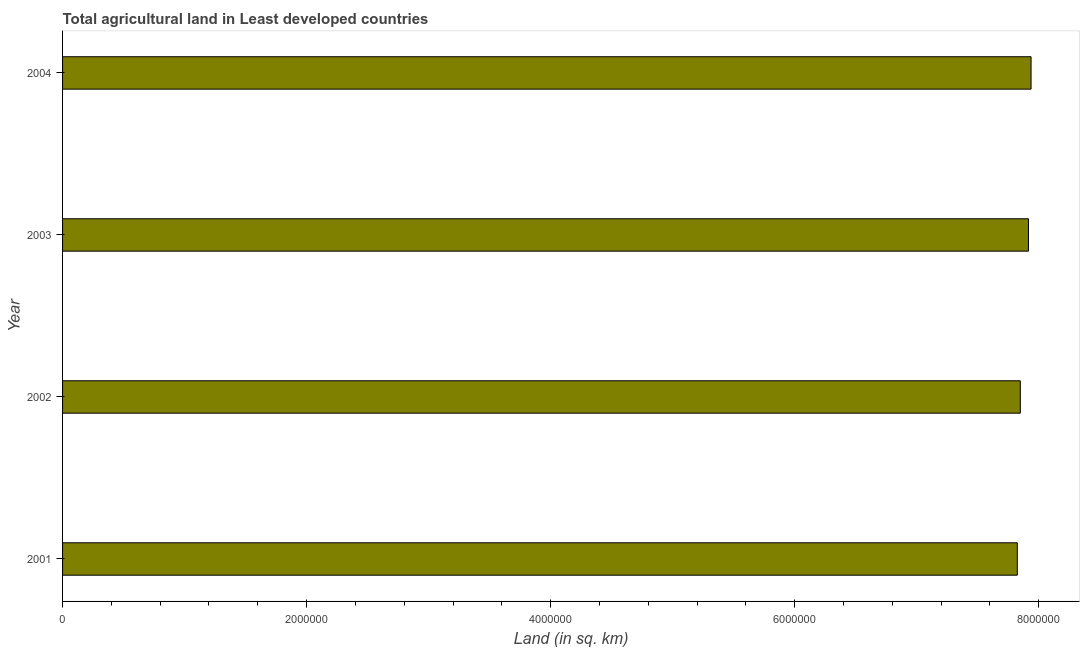What is the title of the graph?
Your response must be concise. Total agricultural land in Least developed countries. What is the label or title of the X-axis?
Your answer should be compact. Land (in sq. km). What is the agricultural land in 2004?
Your response must be concise. 7.94e+06. Across all years, what is the maximum agricultural land?
Offer a terse response. 7.94e+06. Across all years, what is the minimum agricultural land?
Provide a short and direct response. 7.83e+06. In which year was the agricultural land maximum?
Provide a succinct answer. 2004. In which year was the agricultural land minimum?
Give a very brief answer. 2001. What is the sum of the agricultural land?
Offer a very short reply. 3.15e+07. What is the difference between the agricultural land in 2002 and 2004?
Give a very brief answer. -8.82e+04. What is the average agricultural land per year?
Your answer should be compact. 7.88e+06. What is the median agricultural land?
Make the answer very short. 7.88e+06. In how many years, is the agricultural land greater than 2800000 sq. km?
Provide a succinct answer. 4. Do a majority of the years between 2002 and 2004 (inclusive) have agricultural land greater than 6000000 sq. km?
Offer a very short reply. Yes. What is the difference between the highest and the second highest agricultural land?
Give a very brief answer. 2.13e+04. What is the difference between the highest and the lowest agricultural land?
Your answer should be compact. 1.13e+05. What is the difference between two consecutive major ticks on the X-axis?
Provide a succinct answer. 2.00e+06. Are the values on the major ticks of X-axis written in scientific E-notation?
Give a very brief answer. No. What is the Land (in sq. km) of 2001?
Your answer should be compact. 7.83e+06. What is the Land (in sq. km) of 2002?
Your answer should be very brief. 7.85e+06. What is the Land (in sq. km) of 2003?
Your response must be concise. 7.92e+06. What is the Land (in sq. km) of 2004?
Provide a succinct answer. 7.94e+06. What is the difference between the Land (in sq. km) in 2001 and 2002?
Your answer should be very brief. -2.46e+04. What is the difference between the Land (in sq. km) in 2001 and 2003?
Ensure brevity in your answer.  -9.15e+04. What is the difference between the Land (in sq. km) in 2001 and 2004?
Offer a terse response. -1.13e+05. What is the difference between the Land (in sq. km) in 2002 and 2003?
Ensure brevity in your answer.  -6.69e+04. What is the difference between the Land (in sq. km) in 2002 and 2004?
Make the answer very short. -8.82e+04. What is the difference between the Land (in sq. km) in 2003 and 2004?
Your response must be concise. -2.13e+04. What is the ratio of the Land (in sq. km) in 2001 to that in 2002?
Provide a succinct answer. 1. What is the ratio of the Land (in sq. km) in 2003 to that in 2004?
Your response must be concise. 1. 